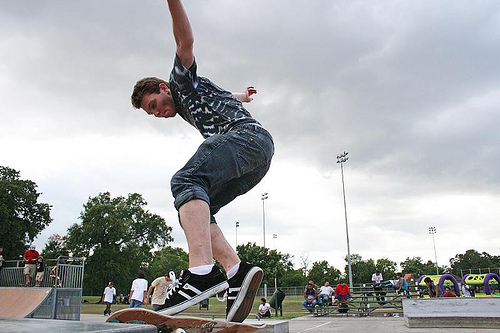<image>
Can you confirm if the sky is behind the pillar? Yes. From this viewpoint, the sky is positioned behind the pillar, with the pillar partially or fully occluding the sky. 